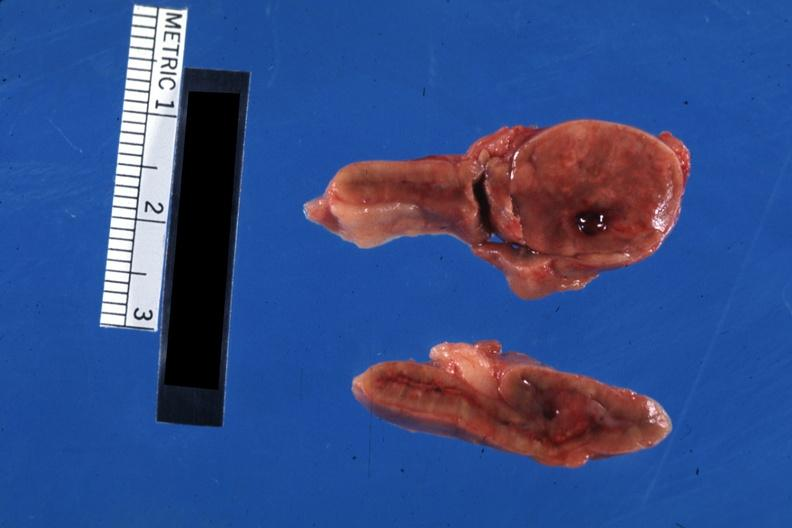what is present?
Answer the question using a single word or phrase. Cortical nodule 